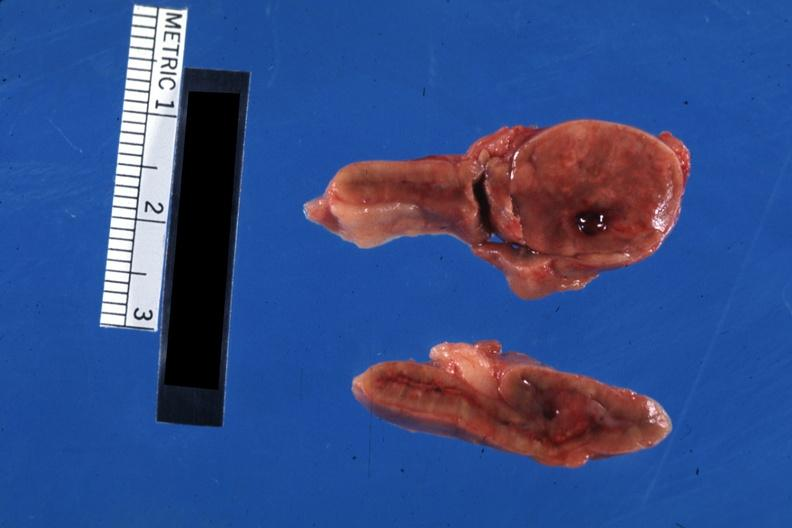what is present?
Answer the question using a single word or phrase. Cortical nodule 